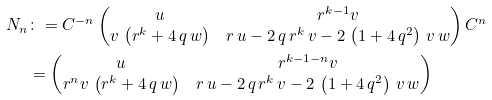Convert formula to latex. <formula><loc_0><loc_0><loc_500><loc_500>N _ { n } & \colon = C ^ { - n } \left ( \begin{matrix} u & r ^ { k - 1 } v \\ v \, \left ( r ^ { k } + 4 \, q \, w \right ) & r \, u - 2 \, q \, r ^ { k } \, v - 2 \, \left ( 1 + 4 \, q ^ { 2 } \right ) \, v \, w \end{matrix} \right ) C ^ { n } \\ & = \left ( \begin{matrix} u & r ^ { k - 1 - n } v \\ r ^ { n } v \, \left ( r ^ { k } + 4 \, q \, w \right ) & r \, u - 2 \, q \, r ^ { k } \, v - 2 \, \left ( 1 + 4 \, q ^ { 2 } \right ) \, v \, w \end{matrix} \right )</formula> 